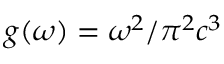<formula> <loc_0><loc_0><loc_500><loc_500>g ( \omega ) = \omega ^ { 2 } / \pi ^ { 2 } c ^ { 3 }</formula> 